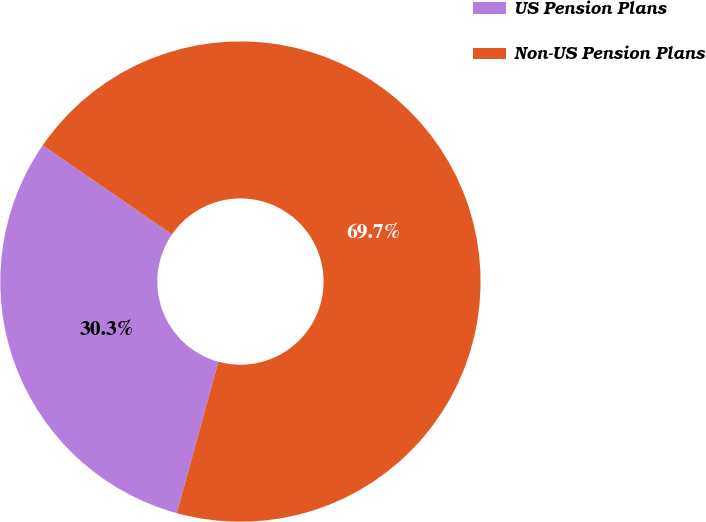<chart> <loc_0><loc_0><loc_500><loc_500><pie_chart><fcel>US Pension Plans<fcel>Non-US Pension Plans<nl><fcel>30.33%<fcel>69.67%<nl></chart> 